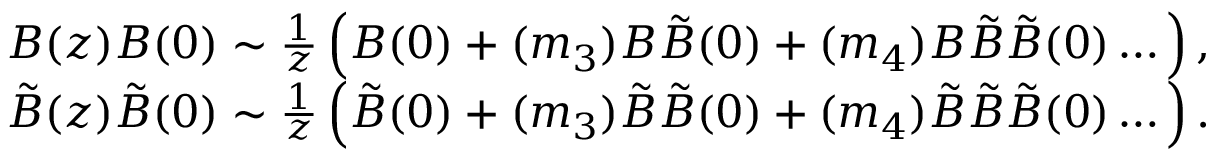<formula> <loc_0><loc_0><loc_500><loc_500>\begin{array} { r } { B ( z ) B ( 0 ) \sim \frac { 1 } { z } \left ( B ( 0 ) + ( m _ { 3 } ) B \tilde { B } ( 0 ) + ( m _ { 4 } ) B \tilde { B } \tilde { B } ( 0 ) \dots \right ) , } \\ { \tilde { B } ( z ) \tilde { B } ( 0 ) \sim \frac { 1 } { z } \left ( \tilde { B } ( 0 ) + ( m _ { 3 } ) \tilde { B } \tilde { B } ( 0 ) + ( m _ { 4 } ) \tilde { B } \tilde { B } \tilde { B } ( 0 ) \dots \right ) . } \end{array}</formula> 